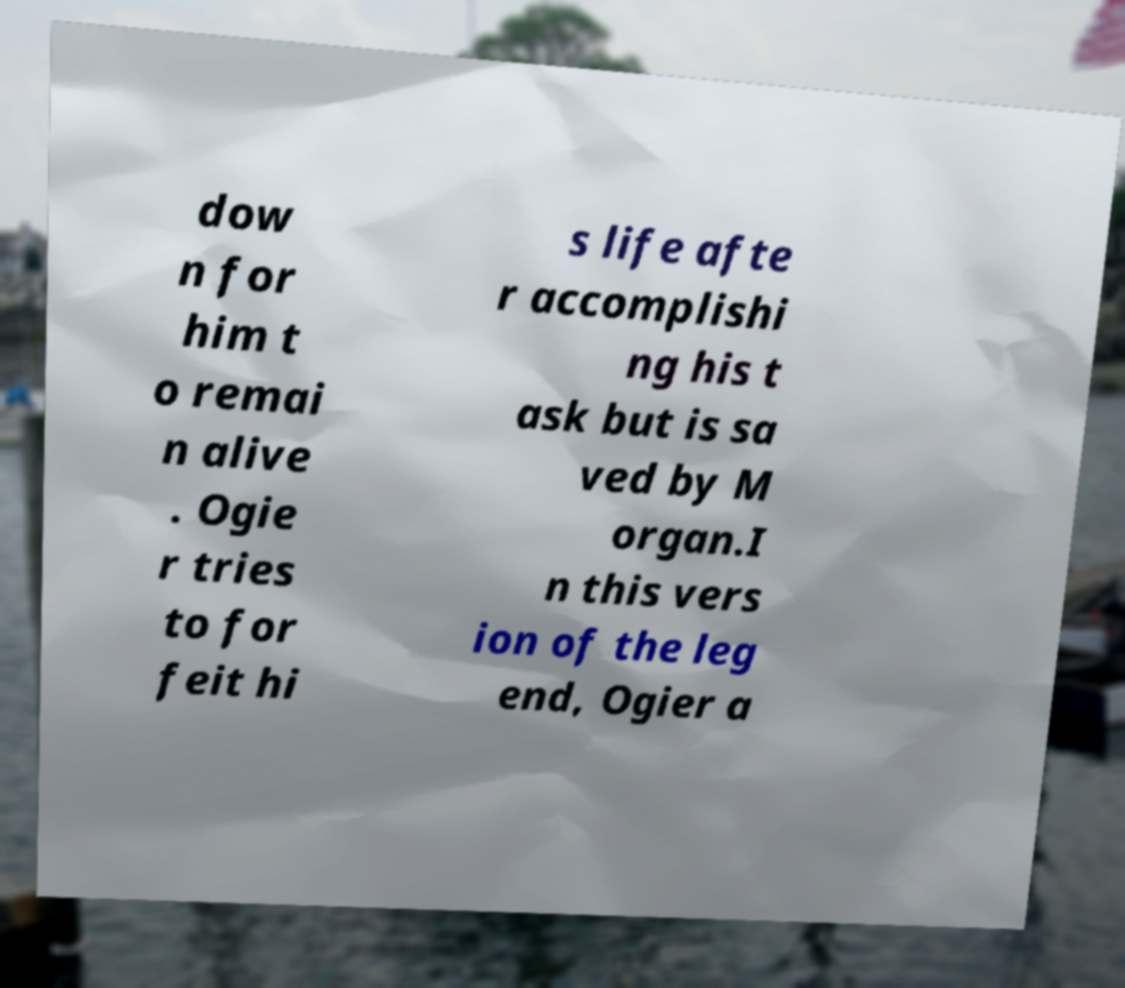Please identify and transcribe the text found in this image. dow n for him t o remai n alive . Ogie r tries to for feit hi s life afte r accomplishi ng his t ask but is sa ved by M organ.I n this vers ion of the leg end, Ogier a 